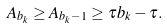Convert formula to latex. <formula><loc_0><loc_0><loc_500><loc_500>A _ { b _ { k } } \geq A _ { b _ { k } - 1 } \geq \tau b _ { k } - \tau .</formula> 